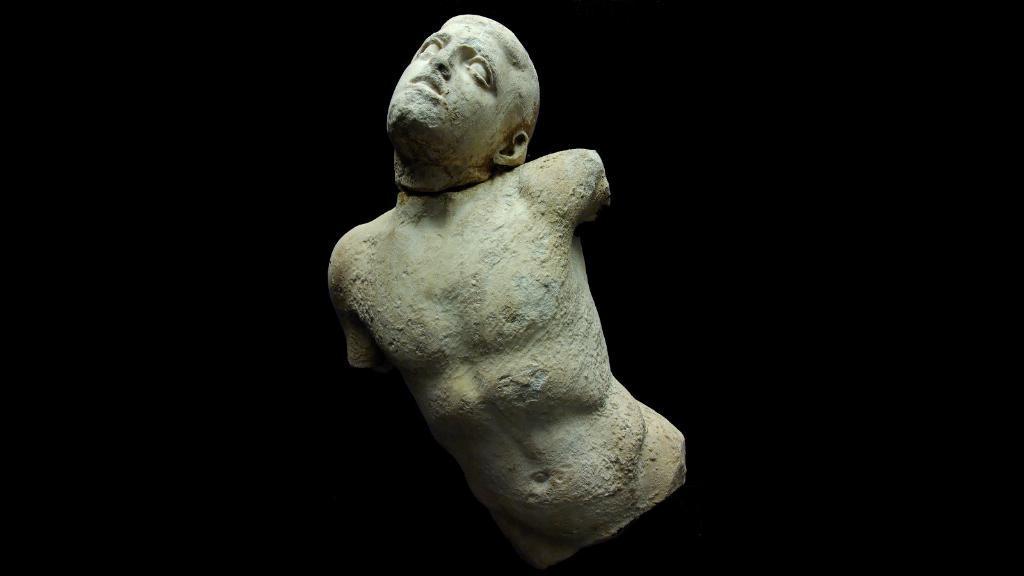Can you describe this image briefly? In the picture we can see a sculpture of a human body without legs and hands, only with a head bent. 